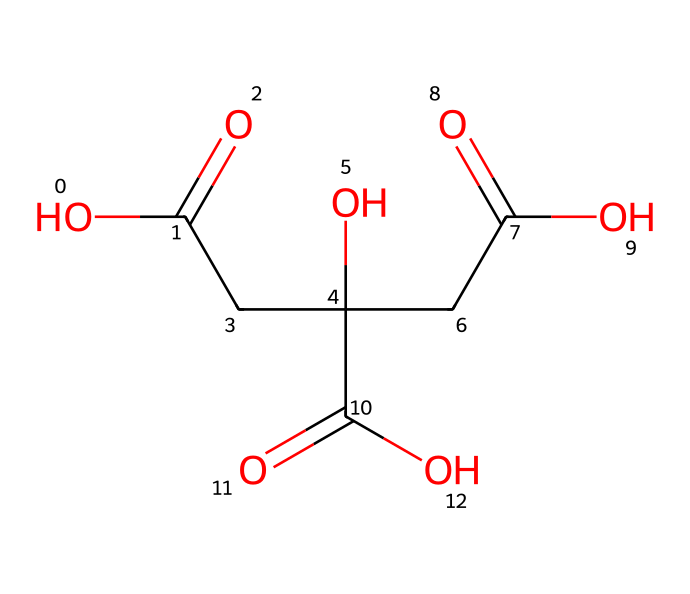What is the name of this chemical? The structure corresponds to citric acid, which is commonly found in citrus fruits. The multiple carboxylic acid groups in the structure indicate it is citric acid, known for its tangy flavor.
Answer: citric acid How many carbon atoms are in citric acid? By examining the structure, we can count the carbon atoms. There are six carbon atoms in citric acid, as indicated by the carbon backbone of the molecule.
Answer: six How many oxygen atoms are present? In the SMILES representation, we can visually identify the oxygen atoms. The presence of three carboxylic acid groups suggests there are a total of eight oxygen atoms in the structure.
Answer: eight Do carboxylic acid groups contribute to the sour taste of citric acid? Yes. The carboxylic acid groups, which release hydrogen ions in solution, contribute to the sour taste of citric acid. The acidic nature is a characteristic of these groups.
Answer: yes What type of functional groups are present in citric acid? The primary functional groups in citric acid include three carboxylic acid groups, which can be identified by their -COOH notation in the structure. These groups define the acid's characteristics.
Answer: carboxylic acid Is citric acid a strong or weak acid? Citric acid is classified as a weak acid. It does not completely dissociate in water, which is typical for weak acids, and this is evident from its structure and behavior in solution.
Answer: weak How does the molecular structure of citric acid impact its solubility in water? The presence of multiple polar carboxylic acid functional groups enhances the solubility of citric acid in water due to hydrogen bonding interactions with water molecules. This is a key reason why citric acid dissolves readily in water.
Answer: high solubility 